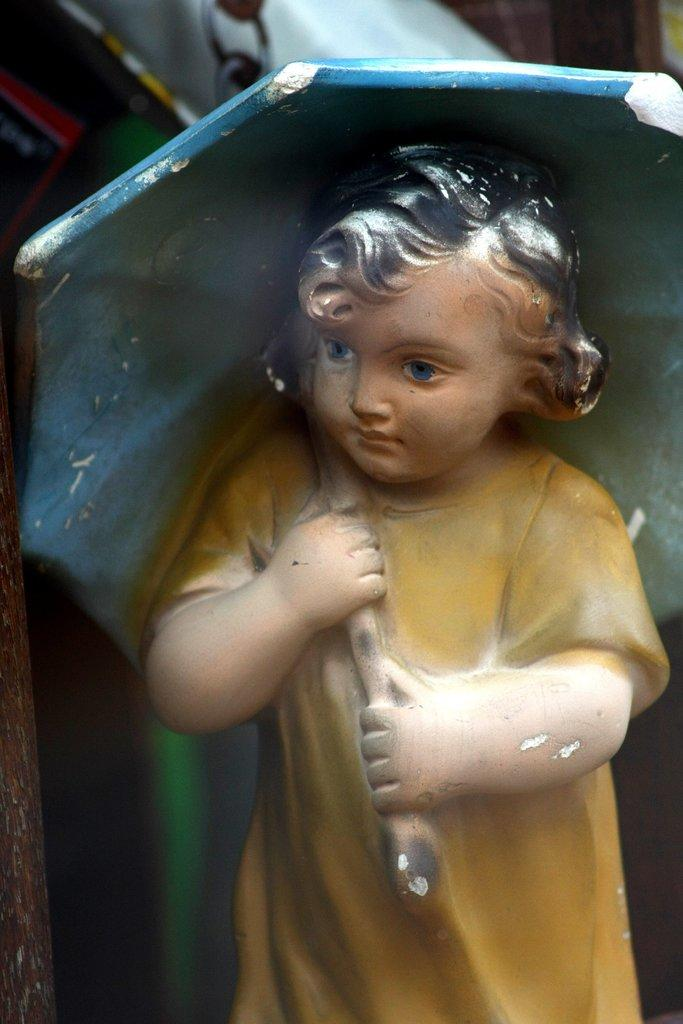What is the main subject of the image? The main subject of the image is an idol of a baby. What is the baby holding in the image? The baby is holding an umbrella in the image. What type of card is the baby holding in the image? There is no card present in the image; the baby is holding an umbrella. 